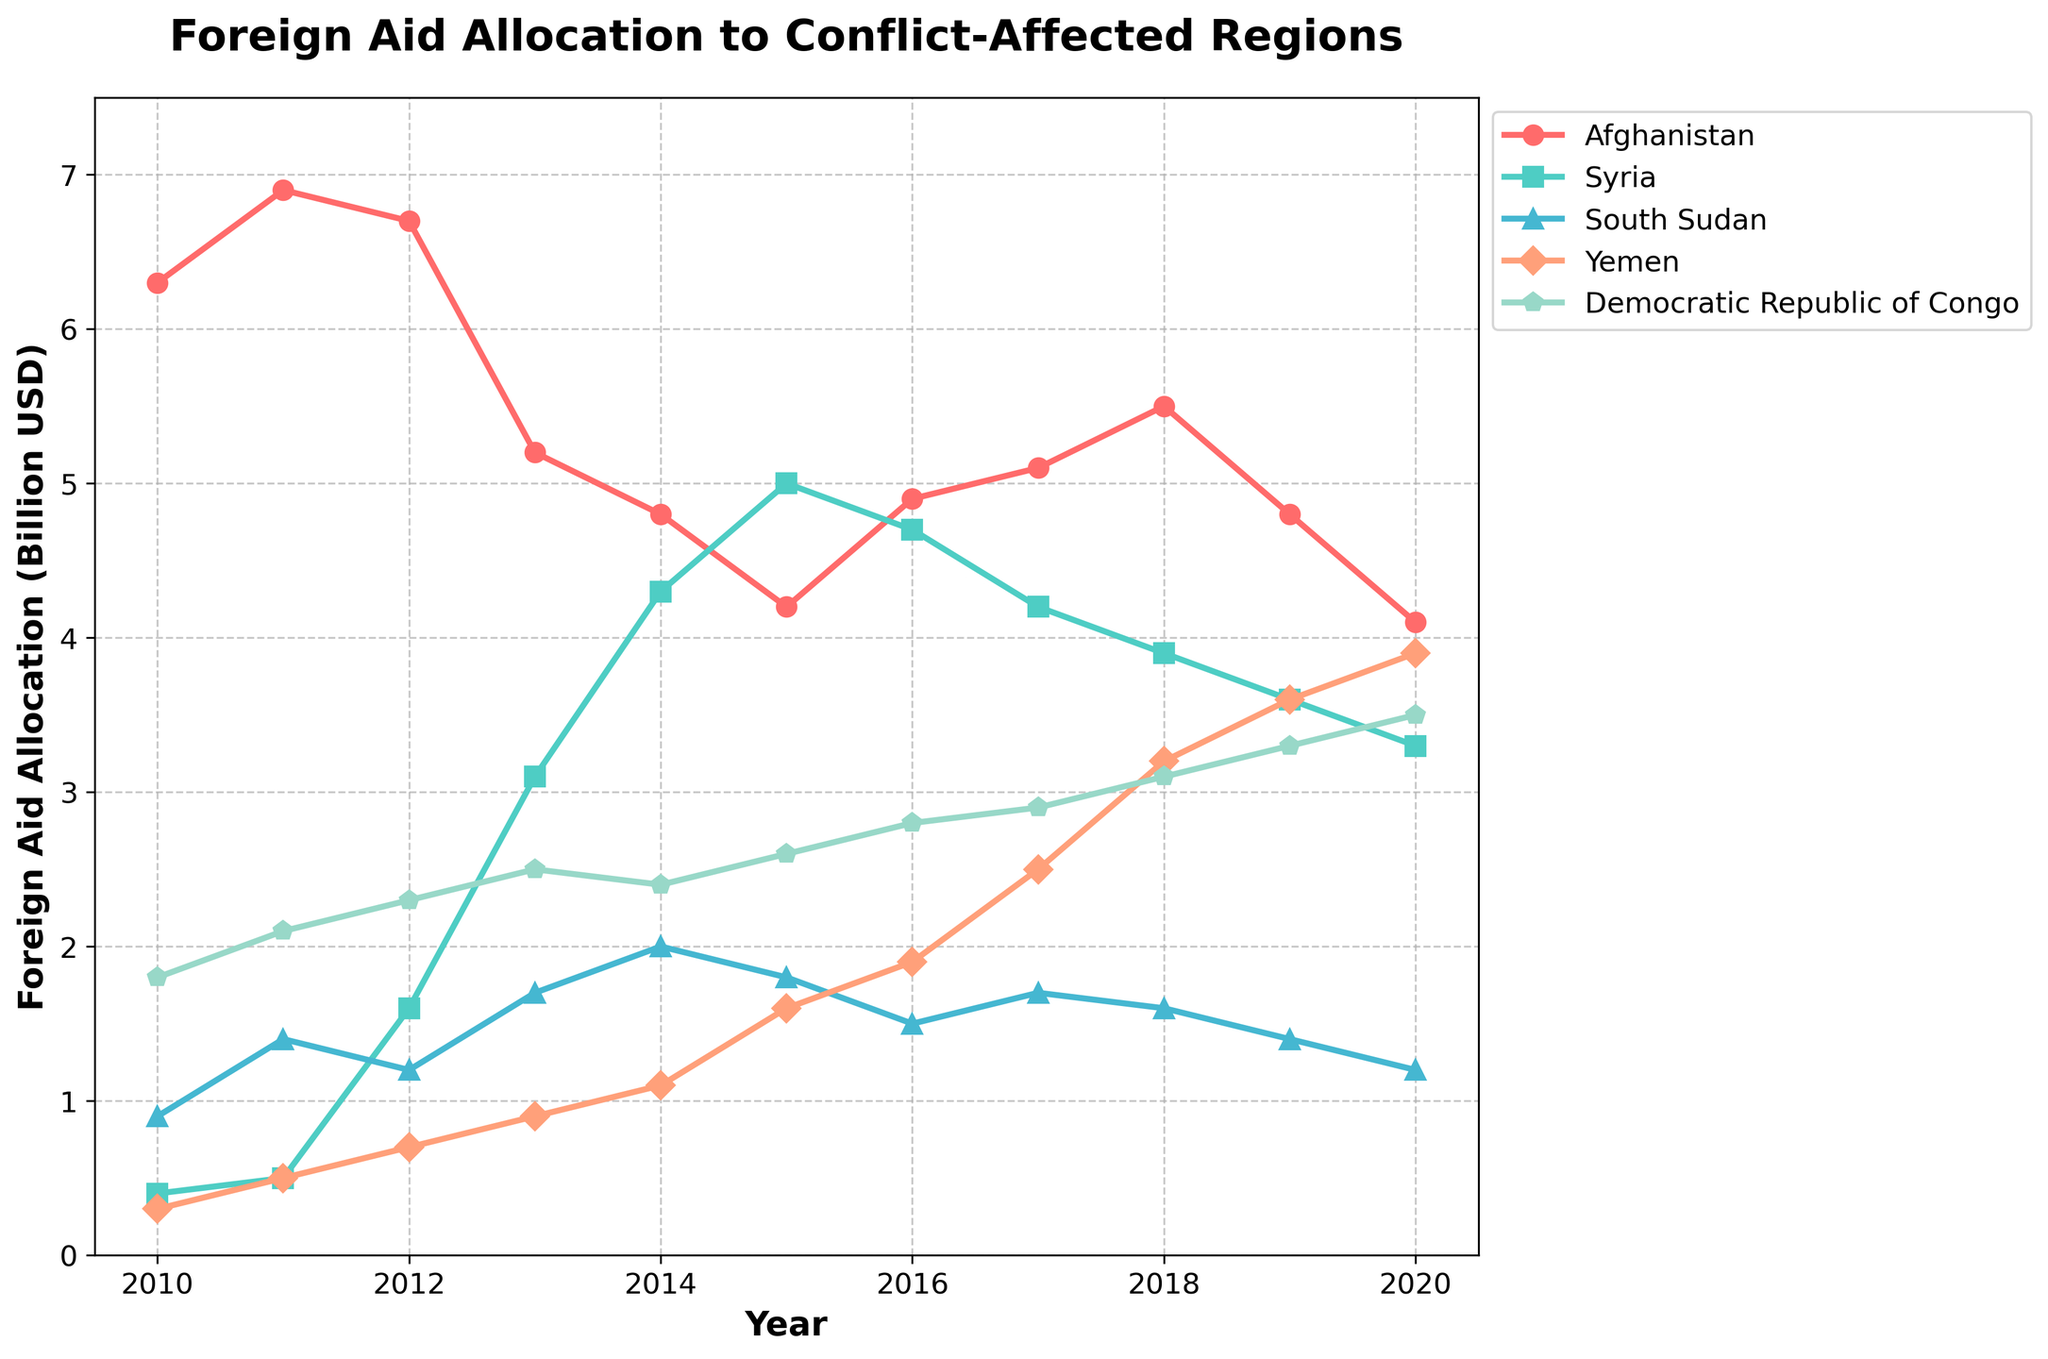How did the foreign aid allocation to Syria change from 2013 to 2014? From the figure, in 2013, Syria received around 3.1 billion USD in foreign aid, and in 2014, it received around 4.3 billion USD. The change is 4.3 - 3.1, which is an increase of 1.2 billion USD.
Answer: Increased by 1.2 billion USD Which country received the highest amount of foreign aid in 2017? Looking at the figure, Afghanistan received around 5.1 billion USD, Syria around 4.2 billion USD, South Sudan around 1.7 billion USD, Yemen around 2.5 billion USD, and the Democratic Republic of Congo around 2.9 billion USD in 2017. Afghanistan has the highest value.
Answer: Afghanistan What is the trend of foreign aid allocation to Yemen from 2010 to 2020? Observing the figure, Yemen shows a consistent increase from 0.3 billion USD in 2010 to 3.9 billion USD in 2020, indicating a rising trend overall.
Answer: Increasing Compare the foreign aid to Afghanistan and the Democratic Republic of Congo in 2015. Which country received more? In 2015, Afghanistan received around 4.2 billion USD, while the Democratic Republic of Congo received around 2.6 billion USD according to the figure. Afghanistan received more.
Answer: Afghanistan What is the average foreign aid allocation to South Sudan over the period 2010-2020? Add up the values for each year for South Sudan from 2010 to 2020: 0.9 + 1.4 + 1.2 + 1.7 + 2.0 + 1.8 + 1.5 + 1.7 + 1.6 + 1.4 + 1.2 = 15.4 billion USD. Divide by the 11 years: 15.4 / 11.
Answer: 1.4 billion USD Based on the figure, during which year did Yemen see the largest single-year increase in foreign aid? By examining the figure, the largest single-year increase for Yemen is from 2014 to 2015, where it went from around 1.1 billion USD to 1.6 billion USD, an increase of 0.5 billion USD.
Answer: 2015 Evaluate the foreign aid to Syria and Yemen in 2020. How do they compare? In 2020, according to the figure, Syria received around 3.3 billion USD, and Yemen received around 3.9 billion USD. Yemen received more aid than Syria in 2020.
Answer: Yemen received more Identify the years in which Afghanistan's foreign aid was below 5 billion USD. From the figure, Afghanistan received below 5 billion USD in 2014, 2015, 2016, 2019, and 2020.
Answer: 2014, 2015, 2016, 2019, 2020 What is the overall trend of foreign aid to the Democratic Republic of Congo from 2010 to 2020? Observing the figure, the Democratic Republic of Congo shows a generally increasing trend, starting from 1.8 billion USD in 2010 to 3.5 billion USD in 2020.
Answer: Increasing How much did the foreign aid to Afghanistan decrease from 2012 to 2014? From the figure, Afghanistan received around 6.7 billion USD in 2012 and around 4.8 billion USD in 2014. The decrease is 6.7 - 4.8, which equals 1.9 billion USD.
Answer: 1.9 billion USD_decrease 